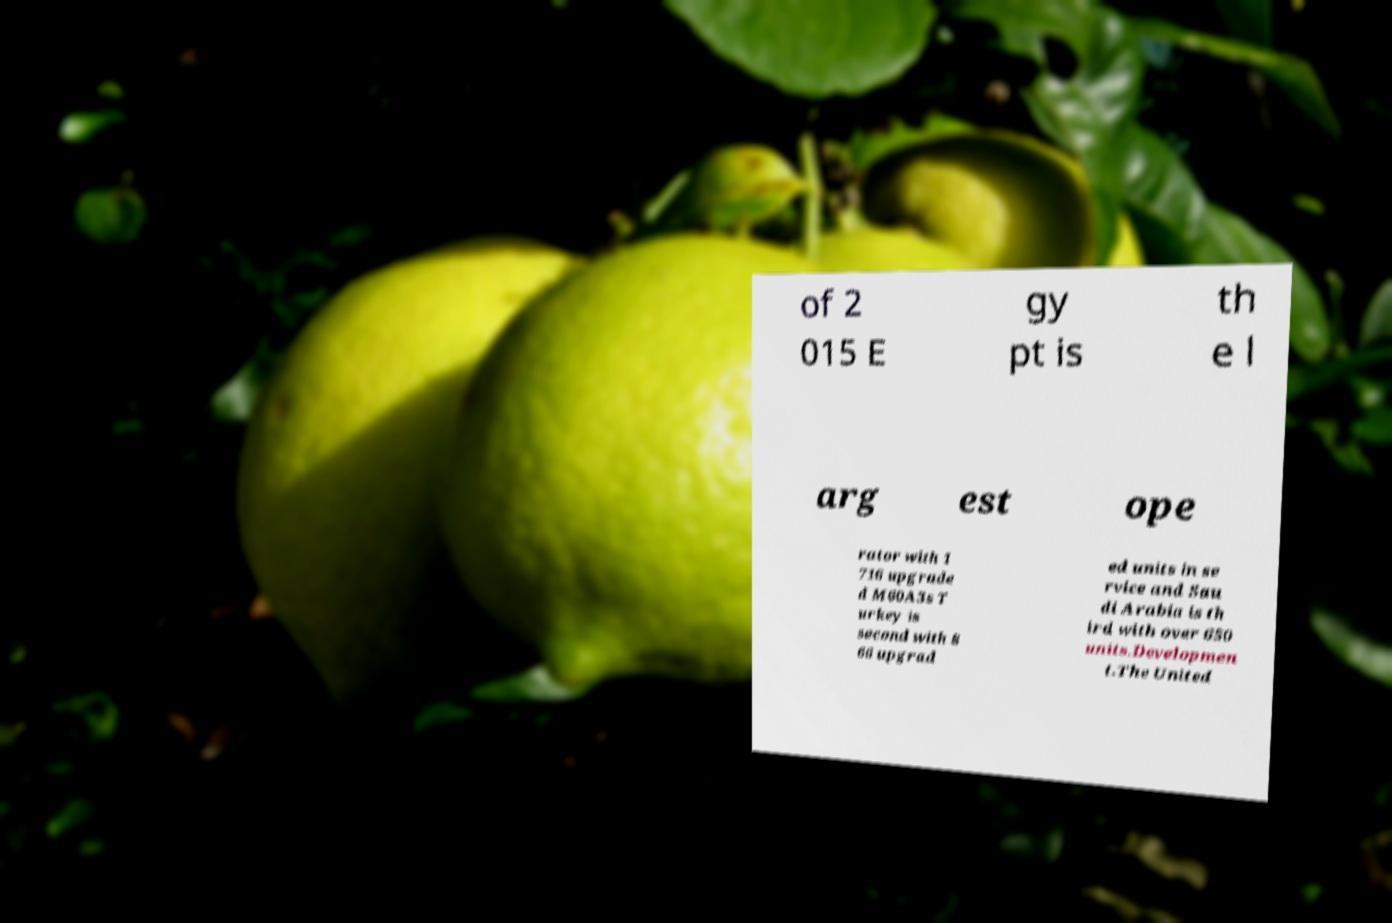Please read and relay the text visible in this image. What does it say? of 2 015 E gy pt is th e l arg est ope rator with 1 716 upgrade d M60A3s T urkey is second with 8 66 upgrad ed units in se rvice and Sau di Arabia is th ird with over 650 units.Developmen t.The United 